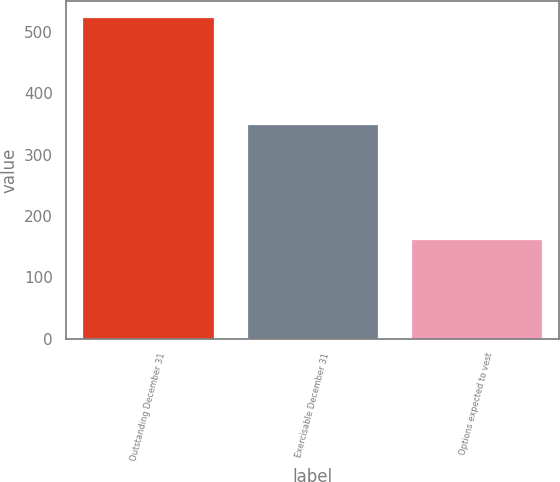<chart> <loc_0><loc_0><loc_500><loc_500><bar_chart><fcel>Outstanding December 31<fcel>Exercisable December 31<fcel>Options expected to vest<nl><fcel>524.2<fcel>349.7<fcel>163.2<nl></chart> 